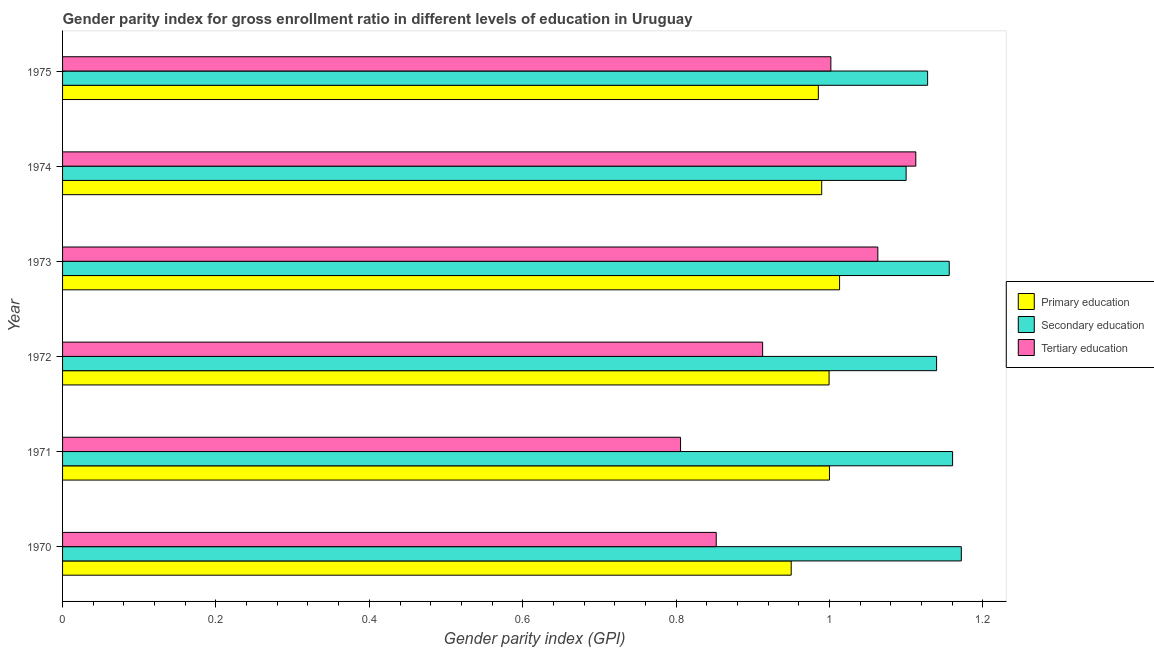How many groups of bars are there?
Give a very brief answer. 6. Are the number of bars per tick equal to the number of legend labels?
Offer a terse response. Yes. How many bars are there on the 6th tick from the top?
Your answer should be very brief. 3. What is the label of the 1st group of bars from the top?
Offer a very short reply. 1975. In how many cases, is the number of bars for a given year not equal to the number of legend labels?
Offer a terse response. 0. What is the gender parity index in tertiary education in 1975?
Your response must be concise. 1. Across all years, what is the maximum gender parity index in tertiary education?
Offer a very short reply. 1.11. Across all years, what is the minimum gender parity index in tertiary education?
Your answer should be compact. 0.81. In which year was the gender parity index in secondary education maximum?
Provide a succinct answer. 1970. In which year was the gender parity index in primary education minimum?
Your response must be concise. 1970. What is the total gender parity index in secondary education in the graph?
Offer a very short reply. 6.86. What is the difference between the gender parity index in primary education in 1972 and that in 1974?
Your answer should be compact. 0.01. What is the difference between the gender parity index in tertiary education in 1974 and the gender parity index in secondary education in 1971?
Your answer should be very brief. -0.05. What is the average gender parity index in secondary education per year?
Ensure brevity in your answer.  1.14. In the year 1974, what is the difference between the gender parity index in secondary education and gender parity index in primary education?
Provide a short and direct response. 0.11. What is the ratio of the gender parity index in tertiary education in 1973 to that in 1975?
Your answer should be compact. 1.06. Is the gender parity index in tertiary education in 1972 less than that in 1973?
Your answer should be very brief. Yes. What is the difference between the highest and the second highest gender parity index in secondary education?
Provide a succinct answer. 0.01. What is the difference between the highest and the lowest gender parity index in secondary education?
Your response must be concise. 0.07. In how many years, is the gender parity index in secondary education greater than the average gender parity index in secondary education taken over all years?
Provide a short and direct response. 3. Is the sum of the gender parity index in tertiary education in 1971 and 1973 greater than the maximum gender parity index in primary education across all years?
Ensure brevity in your answer.  Yes. What does the 2nd bar from the top in 1975 represents?
Keep it short and to the point. Secondary education. What does the 2nd bar from the bottom in 1973 represents?
Provide a short and direct response. Secondary education. Is it the case that in every year, the sum of the gender parity index in primary education and gender parity index in secondary education is greater than the gender parity index in tertiary education?
Ensure brevity in your answer.  Yes. How many years are there in the graph?
Provide a succinct answer. 6. Are the values on the major ticks of X-axis written in scientific E-notation?
Your answer should be very brief. No. Does the graph contain any zero values?
Provide a succinct answer. No. Does the graph contain grids?
Offer a very short reply. No. How many legend labels are there?
Keep it short and to the point. 3. What is the title of the graph?
Your response must be concise. Gender parity index for gross enrollment ratio in different levels of education in Uruguay. What is the label or title of the X-axis?
Give a very brief answer. Gender parity index (GPI). What is the label or title of the Y-axis?
Make the answer very short. Year. What is the Gender parity index (GPI) of Primary education in 1970?
Offer a terse response. 0.95. What is the Gender parity index (GPI) of Secondary education in 1970?
Ensure brevity in your answer.  1.17. What is the Gender parity index (GPI) in Tertiary education in 1970?
Provide a short and direct response. 0.85. What is the Gender parity index (GPI) in Primary education in 1971?
Provide a succinct answer. 1. What is the Gender parity index (GPI) of Secondary education in 1971?
Keep it short and to the point. 1.16. What is the Gender parity index (GPI) of Tertiary education in 1971?
Provide a succinct answer. 0.81. What is the Gender parity index (GPI) of Primary education in 1972?
Give a very brief answer. 1. What is the Gender parity index (GPI) in Secondary education in 1972?
Keep it short and to the point. 1.14. What is the Gender parity index (GPI) in Tertiary education in 1972?
Ensure brevity in your answer.  0.91. What is the Gender parity index (GPI) of Primary education in 1973?
Provide a succinct answer. 1.01. What is the Gender parity index (GPI) of Secondary education in 1973?
Give a very brief answer. 1.16. What is the Gender parity index (GPI) in Tertiary education in 1973?
Provide a succinct answer. 1.06. What is the Gender parity index (GPI) of Primary education in 1974?
Offer a very short reply. 0.99. What is the Gender parity index (GPI) of Secondary education in 1974?
Your response must be concise. 1.1. What is the Gender parity index (GPI) of Tertiary education in 1974?
Your answer should be compact. 1.11. What is the Gender parity index (GPI) in Primary education in 1975?
Your answer should be compact. 0.99. What is the Gender parity index (GPI) in Secondary education in 1975?
Offer a terse response. 1.13. What is the Gender parity index (GPI) in Tertiary education in 1975?
Ensure brevity in your answer.  1. Across all years, what is the maximum Gender parity index (GPI) in Primary education?
Your answer should be very brief. 1.01. Across all years, what is the maximum Gender parity index (GPI) in Secondary education?
Give a very brief answer. 1.17. Across all years, what is the maximum Gender parity index (GPI) of Tertiary education?
Your answer should be compact. 1.11. Across all years, what is the minimum Gender parity index (GPI) in Primary education?
Offer a very short reply. 0.95. Across all years, what is the minimum Gender parity index (GPI) of Secondary education?
Your response must be concise. 1.1. Across all years, what is the minimum Gender parity index (GPI) of Tertiary education?
Provide a succinct answer. 0.81. What is the total Gender parity index (GPI) of Primary education in the graph?
Give a very brief answer. 5.94. What is the total Gender parity index (GPI) of Secondary education in the graph?
Provide a short and direct response. 6.86. What is the total Gender parity index (GPI) in Tertiary education in the graph?
Provide a succinct answer. 5.75. What is the difference between the Gender parity index (GPI) of Primary education in 1970 and that in 1971?
Your answer should be compact. -0.05. What is the difference between the Gender parity index (GPI) in Secondary education in 1970 and that in 1971?
Offer a terse response. 0.01. What is the difference between the Gender parity index (GPI) of Tertiary education in 1970 and that in 1971?
Your response must be concise. 0.05. What is the difference between the Gender parity index (GPI) in Primary education in 1970 and that in 1972?
Your answer should be compact. -0.05. What is the difference between the Gender parity index (GPI) in Secondary education in 1970 and that in 1972?
Make the answer very short. 0.03. What is the difference between the Gender parity index (GPI) in Tertiary education in 1970 and that in 1972?
Your response must be concise. -0.06. What is the difference between the Gender parity index (GPI) of Primary education in 1970 and that in 1973?
Keep it short and to the point. -0.06. What is the difference between the Gender parity index (GPI) of Secondary education in 1970 and that in 1973?
Give a very brief answer. 0.02. What is the difference between the Gender parity index (GPI) of Tertiary education in 1970 and that in 1973?
Keep it short and to the point. -0.21. What is the difference between the Gender parity index (GPI) in Primary education in 1970 and that in 1974?
Ensure brevity in your answer.  -0.04. What is the difference between the Gender parity index (GPI) of Secondary education in 1970 and that in 1974?
Provide a short and direct response. 0.07. What is the difference between the Gender parity index (GPI) of Tertiary education in 1970 and that in 1974?
Offer a very short reply. -0.26. What is the difference between the Gender parity index (GPI) in Primary education in 1970 and that in 1975?
Your answer should be compact. -0.04. What is the difference between the Gender parity index (GPI) of Secondary education in 1970 and that in 1975?
Ensure brevity in your answer.  0.04. What is the difference between the Gender parity index (GPI) of Tertiary education in 1970 and that in 1975?
Keep it short and to the point. -0.15. What is the difference between the Gender parity index (GPI) in Primary education in 1971 and that in 1972?
Make the answer very short. 0. What is the difference between the Gender parity index (GPI) of Secondary education in 1971 and that in 1972?
Keep it short and to the point. 0.02. What is the difference between the Gender parity index (GPI) in Tertiary education in 1971 and that in 1972?
Your response must be concise. -0.11. What is the difference between the Gender parity index (GPI) of Primary education in 1971 and that in 1973?
Keep it short and to the point. -0.01. What is the difference between the Gender parity index (GPI) in Secondary education in 1971 and that in 1973?
Give a very brief answer. 0. What is the difference between the Gender parity index (GPI) of Tertiary education in 1971 and that in 1973?
Provide a succinct answer. -0.26. What is the difference between the Gender parity index (GPI) in Primary education in 1971 and that in 1974?
Offer a terse response. 0.01. What is the difference between the Gender parity index (GPI) in Secondary education in 1971 and that in 1974?
Give a very brief answer. 0.06. What is the difference between the Gender parity index (GPI) in Tertiary education in 1971 and that in 1974?
Your response must be concise. -0.31. What is the difference between the Gender parity index (GPI) in Primary education in 1971 and that in 1975?
Provide a short and direct response. 0.01. What is the difference between the Gender parity index (GPI) of Secondary education in 1971 and that in 1975?
Your response must be concise. 0.03. What is the difference between the Gender parity index (GPI) of Tertiary education in 1971 and that in 1975?
Ensure brevity in your answer.  -0.2. What is the difference between the Gender parity index (GPI) of Primary education in 1972 and that in 1973?
Provide a short and direct response. -0.01. What is the difference between the Gender parity index (GPI) in Secondary education in 1972 and that in 1973?
Provide a short and direct response. -0.02. What is the difference between the Gender parity index (GPI) in Tertiary education in 1972 and that in 1973?
Keep it short and to the point. -0.15. What is the difference between the Gender parity index (GPI) of Primary education in 1972 and that in 1974?
Offer a terse response. 0.01. What is the difference between the Gender parity index (GPI) in Secondary education in 1972 and that in 1974?
Make the answer very short. 0.04. What is the difference between the Gender parity index (GPI) of Tertiary education in 1972 and that in 1974?
Make the answer very short. -0.2. What is the difference between the Gender parity index (GPI) in Primary education in 1972 and that in 1975?
Offer a terse response. 0.01. What is the difference between the Gender parity index (GPI) of Secondary education in 1972 and that in 1975?
Offer a terse response. 0.01. What is the difference between the Gender parity index (GPI) of Tertiary education in 1972 and that in 1975?
Your answer should be compact. -0.09. What is the difference between the Gender parity index (GPI) of Primary education in 1973 and that in 1974?
Your response must be concise. 0.02. What is the difference between the Gender parity index (GPI) in Secondary education in 1973 and that in 1974?
Ensure brevity in your answer.  0.06. What is the difference between the Gender parity index (GPI) in Tertiary education in 1973 and that in 1974?
Your answer should be very brief. -0.05. What is the difference between the Gender parity index (GPI) in Primary education in 1973 and that in 1975?
Offer a terse response. 0.03. What is the difference between the Gender parity index (GPI) in Secondary education in 1973 and that in 1975?
Give a very brief answer. 0.03. What is the difference between the Gender parity index (GPI) in Tertiary education in 1973 and that in 1975?
Keep it short and to the point. 0.06. What is the difference between the Gender parity index (GPI) of Primary education in 1974 and that in 1975?
Your response must be concise. 0. What is the difference between the Gender parity index (GPI) of Secondary education in 1974 and that in 1975?
Keep it short and to the point. -0.03. What is the difference between the Gender parity index (GPI) of Tertiary education in 1974 and that in 1975?
Ensure brevity in your answer.  0.11. What is the difference between the Gender parity index (GPI) of Primary education in 1970 and the Gender parity index (GPI) of Secondary education in 1971?
Provide a succinct answer. -0.21. What is the difference between the Gender parity index (GPI) of Primary education in 1970 and the Gender parity index (GPI) of Tertiary education in 1971?
Provide a short and direct response. 0.14. What is the difference between the Gender parity index (GPI) in Secondary education in 1970 and the Gender parity index (GPI) in Tertiary education in 1971?
Provide a succinct answer. 0.37. What is the difference between the Gender parity index (GPI) in Primary education in 1970 and the Gender parity index (GPI) in Secondary education in 1972?
Make the answer very short. -0.19. What is the difference between the Gender parity index (GPI) of Primary education in 1970 and the Gender parity index (GPI) of Tertiary education in 1972?
Your response must be concise. 0.04. What is the difference between the Gender parity index (GPI) of Secondary education in 1970 and the Gender parity index (GPI) of Tertiary education in 1972?
Offer a very short reply. 0.26. What is the difference between the Gender parity index (GPI) of Primary education in 1970 and the Gender parity index (GPI) of Secondary education in 1973?
Your answer should be very brief. -0.21. What is the difference between the Gender parity index (GPI) in Primary education in 1970 and the Gender parity index (GPI) in Tertiary education in 1973?
Your response must be concise. -0.11. What is the difference between the Gender parity index (GPI) of Secondary education in 1970 and the Gender parity index (GPI) of Tertiary education in 1973?
Give a very brief answer. 0.11. What is the difference between the Gender parity index (GPI) of Primary education in 1970 and the Gender parity index (GPI) of Secondary education in 1974?
Your response must be concise. -0.15. What is the difference between the Gender parity index (GPI) of Primary education in 1970 and the Gender parity index (GPI) of Tertiary education in 1974?
Your response must be concise. -0.16. What is the difference between the Gender parity index (GPI) of Secondary education in 1970 and the Gender parity index (GPI) of Tertiary education in 1974?
Offer a very short reply. 0.06. What is the difference between the Gender parity index (GPI) of Primary education in 1970 and the Gender parity index (GPI) of Secondary education in 1975?
Your answer should be very brief. -0.18. What is the difference between the Gender parity index (GPI) in Primary education in 1970 and the Gender parity index (GPI) in Tertiary education in 1975?
Offer a terse response. -0.05. What is the difference between the Gender parity index (GPI) in Secondary education in 1970 and the Gender parity index (GPI) in Tertiary education in 1975?
Give a very brief answer. 0.17. What is the difference between the Gender parity index (GPI) of Primary education in 1971 and the Gender parity index (GPI) of Secondary education in 1972?
Provide a succinct answer. -0.14. What is the difference between the Gender parity index (GPI) of Primary education in 1971 and the Gender parity index (GPI) of Tertiary education in 1972?
Your response must be concise. 0.09. What is the difference between the Gender parity index (GPI) in Secondary education in 1971 and the Gender parity index (GPI) in Tertiary education in 1972?
Provide a short and direct response. 0.25. What is the difference between the Gender parity index (GPI) of Primary education in 1971 and the Gender parity index (GPI) of Secondary education in 1973?
Provide a succinct answer. -0.16. What is the difference between the Gender parity index (GPI) of Primary education in 1971 and the Gender parity index (GPI) of Tertiary education in 1973?
Provide a succinct answer. -0.06. What is the difference between the Gender parity index (GPI) in Secondary education in 1971 and the Gender parity index (GPI) in Tertiary education in 1973?
Provide a succinct answer. 0.1. What is the difference between the Gender parity index (GPI) in Primary education in 1971 and the Gender parity index (GPI) in Secondary education in 1974?
Offer a very short reply. -0.1. What is the difference between the Gender parity index (GPI) of Primary education in 1971 and the Gender parity index (GPI) of Tertiary education in 1974?
Your answer should be compact. -0.11. What is the difference between the Gender parity index (GPI) in Secondary education in 1971 and the Gender parity index (GPI) in Tertiary education in 1974?
Provide a short and direct response. 0.05. What is the difference between the Gender parity index (GPI) in Primary education in 1971 and the Gender parity index (GPI) in Secondary education in 1975?
Ensure brevity in your answer.  -0.13. What is the difference between the Gender parity index (GPI) in Primary education in 1971 and the Gender parity index (GPI) in Tertiary education in 1975?
Provide a short and direct response. -0. What is the difference between the Gender parity index (GPI) of Secondary education in 1971 and the Gender parity index (GPI) of Tertiary education in 1975?
Your response must be concise. 0.16. What is the difference between the Gender parity index (GPI) of Primary education in 1972 and the Gender parity index (GPI) of Secondary education in 1973?
Your answer should be very brief. -0.16. What is the difference between the Gender parity index (GPI) of Primary education in 1972 and the Gender parity index (GPI) of Tertiary education in 1973?
Keep it short and to the point. -0.06. What is the difference between the Gender parity index (GPI) in Secondary education in 1972 and the Gender parity index (GPI) in Tertiary education in 1973?
Provide a succinct answer. 0.08. What is the difference between the Gender parity index (GPI) of Primary education in 1972 and the Gender parity index (GPI) of Secondary education in 1974?
Give a very brief answer. -0.1. What is the difference between the Gender parity index (GPI) of Primary education in 1972 and the Gender parity index (GPI) of Tertiary education in 1974?
Your answer should be very brief. -0.11. What is the difference between the Gender parity index (GPI) in Secondary education in 1972 and the Gender parity index (GPI) in Tertiary education in 1974?
Keep it short and to the point. 0.03. What is the difference between the Gender parity index (GPI) in Primary education in 1972 and the Gender parity index (GPI) in Secondary education in 1975?
Offer a terse response. -0.13. What is the difference between the Gender parity index (GPI) in Primary education in 1972 and the Gender parity index (GPI) in Tertiary education in 1975?
Ensure brevity in your answer.  -0. What is the difference between the Gender parity index (GPI) in Secondary education in 1972 and the Gender parity index (GPI) in Tertiary education in 1975?
Ensure brevity in your answer.  0.14. What is the difference between the Gender parity index (GPI) in Primary education in 1973 and the Gender parity index (GPI) in Secondary education in 1974?
Your answer should be very brief. -0.09. What is the difference between the Gender parity index (GPI) in Primary education in 1973 and the Gender parity index (GPI) in Tertiary education in 1974?
Offer a very short reply. -0.1. What is the difference between the Gender parity index (GPI) in Secondary education in 1973 and the Gender parity index (GPI) in Tertiary education in 1974?
Provide a short and direct response. 0.04. What is the difference between the Gender parity index (GPI) in Primary education in 1973 and the Gender parity index (GPI) in Secondary education in 1975?
Make the answer very short. -0.11. What is the difference between the Gender parity index (GPI) in Primary education in 1973 and the Gender parity index (GPI) in Tertiary education in 1975?
Offer a terse response. 0.01. What is the difference between the Gender parity index (GPI) in Secondary education in 1973 and the Gender parity index (GPI) in Tertiary education in 1975?
Offer a terse response. 0.15. What is the difference between the Gender parity index (GPI) of Primary education in 1974 and the Gender parity index (GPI) of Secondary education in 1975?
Your response must be concise. -0.14. What is the difference between the Gender parity index (GPI) of Primary education in 1974 and the Gender parity index (GPI) of Tertiary education in 1975?
Offer a terse response. -0.01. What is the difference between the Gender parity index (GPI) of Secondary education in 1974 and the Gender parity index (GPI) of Tertiary education in 1975?
Ensure brevity in your answer.  0.1. What is the average Gender parity index (GPI) in Primary education per year?
Your response must be concise. 0.99. What is the average Gender parity index (GPI) in Secondary education per year?
Your answer should be very brief. 1.14. What is the average Gender parity index (GPI) in Tertiary education per year?
Ensure brevity in your answer.  0.96. In the year 1970, what is the difference between the Gender parity index (GPI) of Primary education and Gender parity index (GPI) of Secondary education?
Your response must be concise. -0.22. In the year 1970, what is the difference between the Gender parity index (GPI) of Primary education and Gender parity index (GPI) of Tertiary education?
Provide a short and direct response. 0.1. In the year 1970, what is the difference between the Gender parity index (GPI) in Secondary education and Gender parity index (GPI) in Tertiary education?
Ensure brevity in your answer.  0.32. In the year 1971, what is the difference between the Gender parity index (GPI) in Primary education and Gender parity index (GPI) in Secondary education?
Offer a very short reply. -0.16. In the year 1971, what is the difference between the Gender parity index (GPI) of Primary education and Gender parity index (GPI) of Tertiary education?
Provide a short and direct response. 0.19. In the year 1971, what is the difference between the Gender parity index (GPI) of Secondary education and Gender parity index (GPI) of Tertiary education?
Ensure brevity in your answer.  0.35. In the year 1972, what is the difference between the Gender parity index (GPI) of Primary education and Gender parity index (GPI) of Secondary education?
Offer a very short reply. -0.14. In the year 1972, what is the difference between the Gender parity index (GPI) of Primary education and Gender parity index (GPI) of Tertiary education?
Offer a terse response. 0.09. In the year 1972, what is the difference between the Gender parity index (GPI) in Secondary education and Gender parity index (GPI) in Tertiary education?
Give a very brief answer. 0.23. In the year 1973, what is the difference between the Gender parity index (GPI) of Primary education and Gender parity index (GPI) of Secondary education?
Offer a terse response. -0.14. In the year 1973, what is the difference between the Gender parity index (GPI) of Primary education and Gender parity index (GPI) of Tertiary education?
Give a very brief answer. -0.05. In the year 1973, what is the difference between the Gender parity index (GPI) of Secondary education and Gender parity index (GPI) of Tertiary education?
Your answer should be very brief. 0.09. In the year 1974, what is the difference between the Gender parity index (GPI) in Primary education and Gender parity index (GPI) in Secondary education?
Offer a very short reply. -0.11. In the year 1974, what is the difference between the Gender parity index (GPI) of Primary education and Gender parity index (GPI) of Tertiary education?
Provide a short and direct response. -0.12. In the year 1974, what is the difference between the Gender parity index (GPI) of Secondary education and Gender parity index (GPI) of Tertiary education?
Your response must be concise. -0.01. In the year 1975, what is the difference between the Gender parity index (GPI) in Primary education and Gender parity index (GPI) in Secondary education?
Provide a short and direct response. -0.14. In the year 1975, what is the difference between the Gender parity index (GPI) of Primary education and Gender parity index (GPI) of Tertiary education?
Provide a succinct answer. -0.02. In the year 1975, what is the difference between the Gender parity index (GPI) of Secondary education and Gender parity index (GPI) of Tertiary education?
Provide a short and direct response. 0.13. What is the ratio of the Gender parity index (GPI) of Primary education in 1970 to that in 1971?
Offer a very short reply. 0.95. What is the ratio of the Gender parity index (GPI) of Secondary education in 1970 to that in 1971?
Ensure brevity in your answer.  1.01. What is the ratio of the Gender parity index (GPI) of Tertiary education in 1970 to that in 1971?
Keep it short and to the point. 1.06. What is the ratio of the Gender parity index (GPI) of Primary education in 1970 to that in 1972?
Provide a short and direct response. 0.95. What is the ratio of the Gender parity index (GPI) in Secondary education in 1970 to that in 1972?
Offer a terse response. 1.03. What is the ratio of the Gender parity index (GPI) in Tertiary education in 1970 to that in 1972?
Ensure brevity in your answer.  0.93. What is the ratio of the Gender parity index (GPI) of Primary education in 1970 to that in 1973?
Provide a succinct answer. 0.94. What is the ratio of the Gender parity index (GPI) in Secondary education in 1970 to that in 1973?
Provide a short and direct response. 1.01. What is the ratio of the Gender parity index (GPI) in Tertiary education in 1970 to that in 1973?
Offer a terse response. 0.8. What is the ratio of the Gender parity index (GPI) of Primary education in 1970 to that in 1974?
Your answer should be compact. 0.96. What is the ratio of the Gender parity index (GPI) of Secondary education in 1970 to that in 1974?
Make the answer very short. 1.07. What is the ratio of the Gender parity index (GPI) of Tertiary education in 1970 to that in 1974?
Your answer should be compact. 0.77. What is the ratio of the Gender parity index (GPI) in Primary education in 1970 to that in 1975?
Your answer should be compact. 0.96. What is the ratio of the Gender parity index (GPI) of Secondary education in 1970 to that in 1975?
Your response must be concise. 1.04. What is the ratio of the Gender parity index (GPI) in Tertiary education in 1970 to that in 1975?
Ensure brevity in your answer.  0.85. What is the ratio of the Gender parity index (GPI) of Secondary education in 1971 to that in 1972?
Give a very brief answer. 1.02. What is the ratio of the Gender parity index (GPI) of Tertiary education in 1971 to that in 1972?
Ensure brevity in your answer.  0.88. What is the ratio of the Gender parity index (GPI) of Primary education in 1971 to that in 1973?
Provide a short and direct response. 0.99. What is the ratio of the Gender parity index (GPI) of Secondary education in 1971 to that in 1973?
Provide a succinct answer. 1. What is the ratio of the Gender parity index (GPI) of Tertiary education in 1971 to that in 1973?
Offer a very short reply. 0.76. What is the ratio of the Gender parity index (GPI) in Primary education in 1971 to that in 1974?
Provide a succinct answer. 1.01. What is the ratio of the Gender parity index (GPI) of Secondary education in 1971 to that in 1974?
Provide a short and direct response. 1.06. What is the ratio of the Gender parity index (GPI) in Tertiary education in 1971 to that in 1974?
Ensure brevity in your answer.  0.72. What is the ratio of the Gender parity index (GPI) of Primary education in 1971 to that in 1975?
Your answer should be very brief. 1.01. What is the ratio of the Gender parity index (GPI) of Secondary education in 1971 to that in 1975?
Offer a very short reply. 1.03. What is the ratio of the Gender parity index (GPI) of Tertiary education in 1971 to that in 1975?
Make the answer very short. 0.8. What is the ratio of the Gender parity index (GPI) of Primary education in 1972 to that in 1973?
Ensure brevity in your answer.  0.99. What is the ratio of the Gender parity index (GPI) in Secondary education in 1972 to that in 1973?
Provide a short and direct response. 0.99. What is the ratio of the Gender parity index (GPI) of Tertiary education in 1972 to that in 1973?
Provide a succinct answer. 0.86. What is the ratio of the Gender parity index (GPI) of Primary education in 1972 to that in 1974?
Provide a short and direct response. 1.01. What is the ratio of the Gender parity index (GPI) of Secondary education in 1972 to that in 1974?
Offer a very short reply. 1.04. What is the ratio of the Gender parity index (GPI) in Tertiary education in 1972 to that in 1974?
Your answer should be very brief. 0.82. What is the ratio of the Gender parity index (GPI) of Primary education in 1972 to that in 1975?
Offer a very short reply. 1.01. What is the ratio of the Gender parity index (GPI) in Secondary education in 1972 to that in 1975?
Your answer should be very brief. 1.01. What is the ratio of the Gender parity index (GPI) in Tertiary education in 1972 to that in 1975?
Your answer should be very brief. 0.91. What is the ratio of the Gender parity index (GPI) of Primary education in 1973 to that in 1974?
Give a very brief answer. 1.02. What is the ratio of the Gender parity index (GPI) of Secondary education in 1973 to that in 1974?
Make the answer very short. 1.05. What is the ratio of the Gender parity index (GPI) of Tertiary education in 1973 to that in 1974?
Ensure brevity in your answer.  0.96. What is the ratio of the Gender parity index (GPI) in Primary education in 1973 to that in 1975?
Give a very brief answer. 1.03. What is the ratio of the Gender parity index (GPI) of Tertiary education in 1973 to that in 1975?
Offer a terse response. 1.06. What is the ratio of the Gender parity index (GPI) of Primary education in 1974 to that in 1975?
Offer a terse response. 1. What is the ratio of the Gender parity index (GPI) in Secondary education in 1974 to that in 1975?
Offer a very short reply. 0.98. What is the ratio of the Gender parity index (GPI) in Tertiary education in 1974 to that in 1975?
Offer a terse response. 1.11. What is the difference between the highest and the second highest Gender parity index (GPI) of Primary education?
Offer a very short reply. 0.01. What is the difference between the highest and the second highest Gender parity index (GPI) in Secondary education?
Make the answer very short. 0.01. What is the difference between the highest and the second highest Gender parity index (GPI) of Tertiary education?
Keep it short and to the point. 0.05. What is the difference between the highest and the lowest Gender parity index (GPI) of Primary education?
Offer a very short reply. 0.06. What is the difference between the highest and the lowest Gender parity index (GPI) of Secondary education?
Give a very brief answer. 0.07. What is the difference between the highest and the lowest Gender parity index (GPI) of Tertiary education?
Provide a short and direct response. 0.31. 